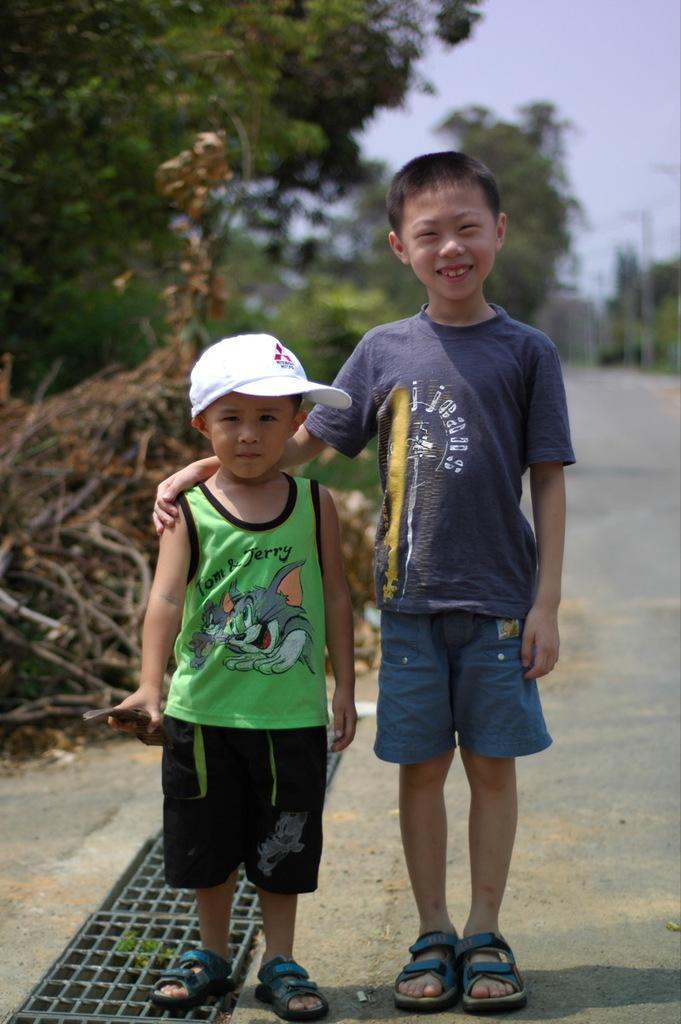How many people are in the image? There are two boys in the image. Where are the boys located in the image? The boys are standing on the road. What can be seen in the background of the image? There are trees and the sky visible in the background of the image. What type of giants can be seen walking on the hill in the image? There are no giants or hills present in the image; it features two boys standing on the road with trees and the sky visible in the background. 